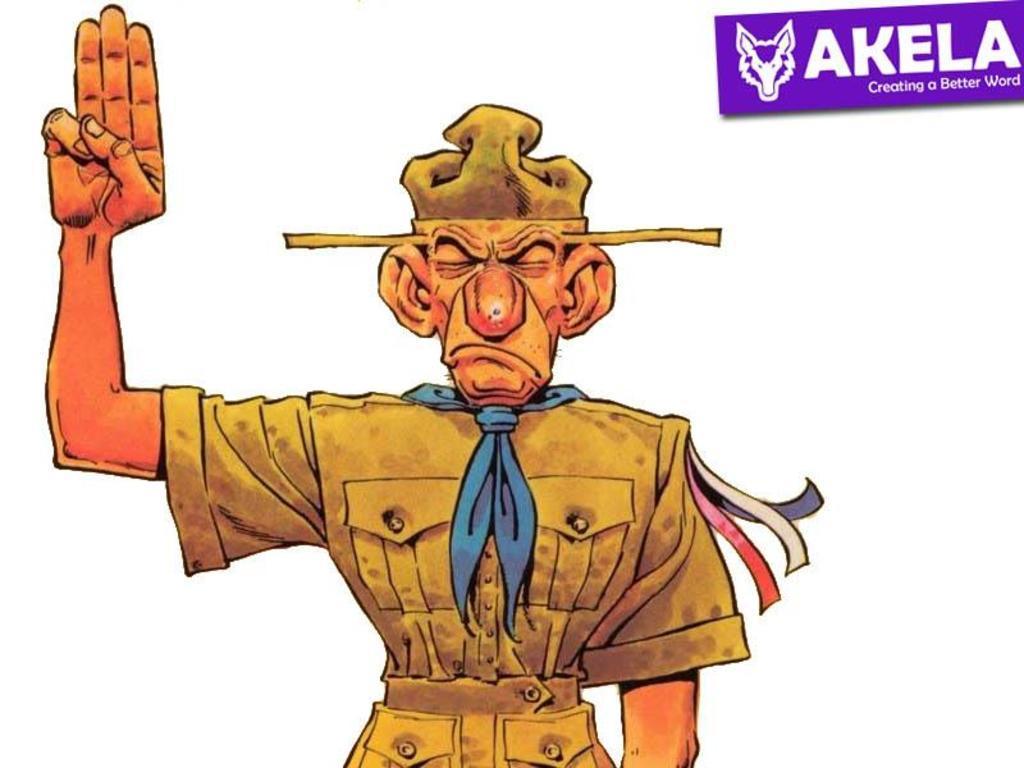Can you describe this image briefly? This image consists of an animated picture. In which we can see a man and a logo. 